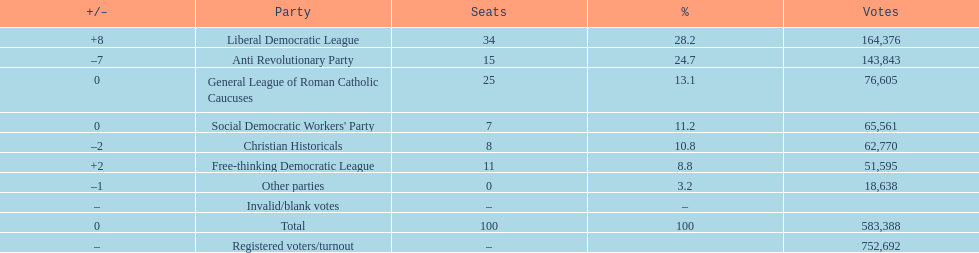After the election, how many seats did the liberal democratic league win? 34. 